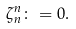Convert formula to latex. <formula><loc_0><loc_0><loc_500><loc_500>\zeta _ { n } ^ { n } \colon = 0 .</formula> 